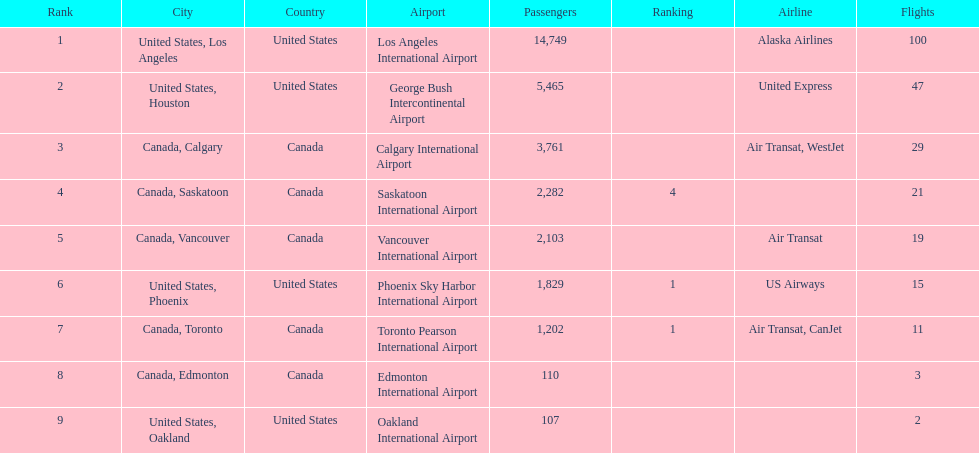Was los angeles or houston the busiest international route at manzanillo international airport in 2013? Los Angeles. Give me the full table as a dictionary. {'header': ['Rank', 'City', 'Country', 'Airport', 'Passengers', 'Ranking', 'Airline', 'Flights'], 'rows': [['1', 'United States, Los Angeles', 'United States', 'Los Angeles International Airport', '14,749', '', 'Alaska Airlines', '100'], ['2', 'United States, Houston', 'United States', 'George Bush Intercontinental Airport', '5,465', '', 'United Express', '47'], ['3', 'Canada, Calgary', 'Canada', 'Calgary International Airport', '3,761', '', 'Air Transat, WestJet', '29'], ['4', 'Canada, Saskatoon', 'Canada', 'Saskatoon International Airport', '2,282', '4', '', '21'], ['5', 'Canada, Vancouver', 'Canada', 'Vancouver International Airport', '2,103', '', 'Air Transat', '19'], ['6', 'United States, Phoenix', 'United States', 'Phoenix Sky Harbor International Airport', '1,829', '1', 'US Airways', '15'], ['7', 'Canada, Toronto', 'Canada', 'Toronto Pearson International Airport', '1,202', '1', 'Air Transat, CanJet', '11'], ['8', 'Canada, Edmonton', 'Canada', 'Edmonton International Airport', '110', '', '', '3'], ['9', 'United States, Oakland', 'United States', 'Oakland International Airport', '107', '', '', '2']]} 